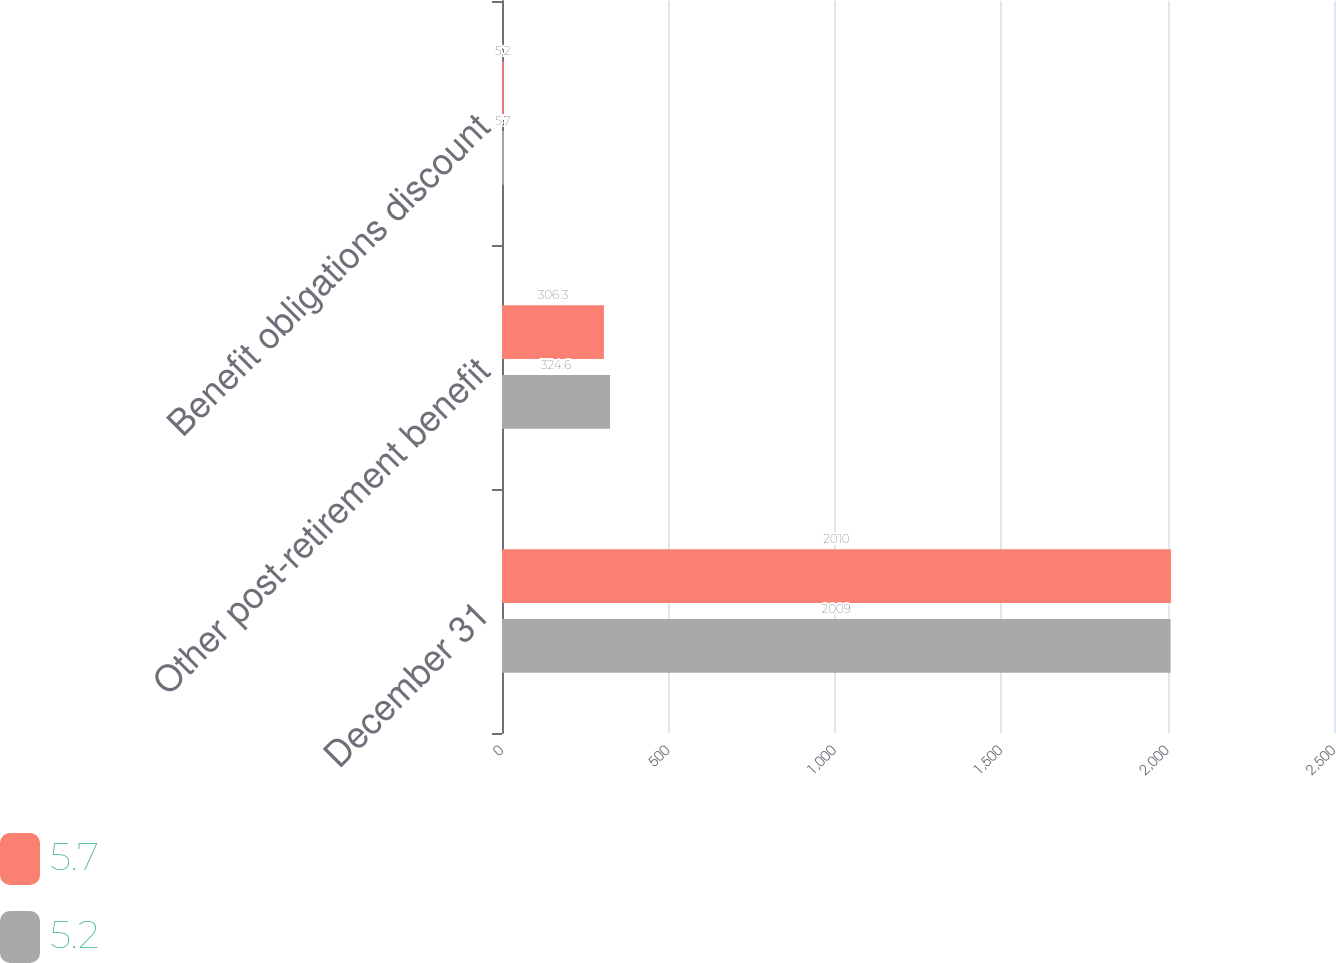Convert chart to OTSL. <chart><loc_0><loc_0><loc_500><loc_500><stacked_bar_chart><ecel><fcel>December 31<fcel>Other post-retirement benefit<fcel>Benefit obligations discount<nl><fcel>5.7<fcel>2010<fcel>306.3<fcel>5.2<nl><fcel>5.2<fcel>2009<fcel>324.6<fcel>5.7<nl></chart> 